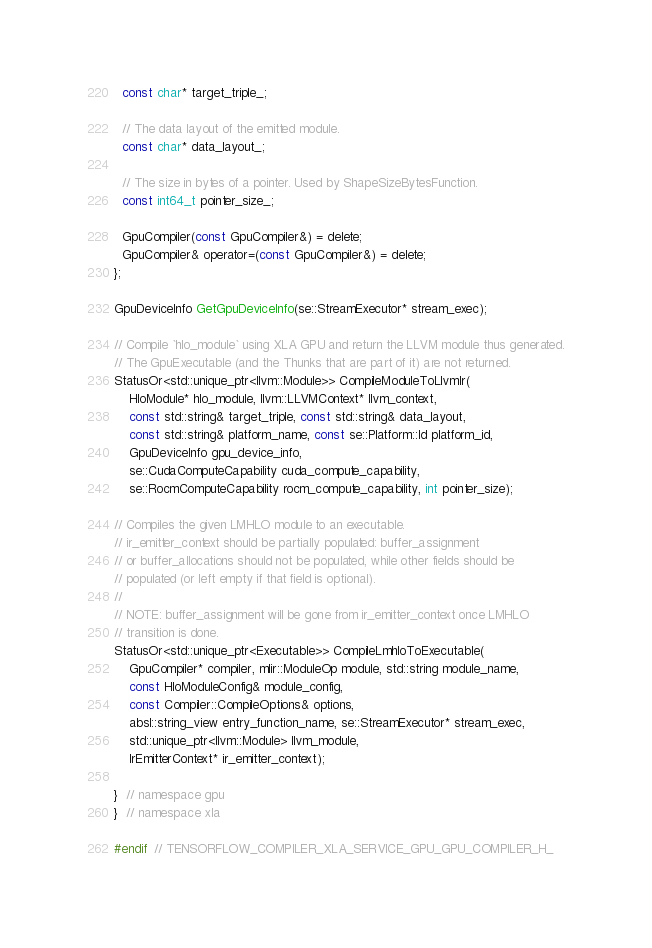<code> <loc_0><loc_0><loc_500><loc_500><_C_>  const char* target_triple_;

  // The data layout of the emitted module.
  const char* data_layout_;

  // The size in bytes of a pointer. Used by ShapeSizeBytesFunction.
  const int64_t pointer_size_;

  GpuCompiler(const GpuCompiler&) = delete;
  GpuCompiler& operator=(const GpuCompiler&) = delete;
};

GpuDeviceInfo GetGpuDeviceInfo(se::StreamExecutor* stream_exec);

// Compile `hlo_module` using XLA GPU and return the LLVM module thus generated.
// The GpuExecutable (and the Thunks that are part of it) are not returned.
StatusOr<std::unique_ptr<llvm::Module>> CompileModuleToLlvmIr(
    HloModule* hlo_module, llvm::LLVMContext* llvm_context,
    const std::string& target_triple, const std::string& data_layout,
    const std::string& platform_name, const se::Platform::Id platform_id,
    GpuDeviceInfo gpu_device_info,
    se::CudaComputeCapability cuda_compute_capability,
    se::RocmComputeCapability rocm_compute_capability, int pointer_size);

// Compiles the given LMHLO module to an executable.
// ir_emitter_context should be partially populated: buffer_assignment
// or buffer_allocations should not be populated, while other fields should be
// populated (or left empty if that field is optional).
//
// NOTE: buffer_assignment will be gone from ir_emitter_context once LMHLO
// transition is done.
StatusOr<std::unique_ptr<Executable>> CompileLmhloToExecutable(
    GpuCompiler* compiler, mlir::ModuleOp module, std::string module_name,
    const HloModuleConfig& module_config,
    const Compiler::CompileOptions& options,
    absl::string_view entry_function_name, se::StreamExecutor* stream_exec,
    std::unique_ptr<llvm::Module> llvm_module,
    IrEmitterContext* ir_emitter_context);

}  // namespace gpu
}  // namespace xla

#endif  // TENSORFLOW_COMPILER_XLA_SERVICE_GPU_GPU_COMPILER_H_
</code> 